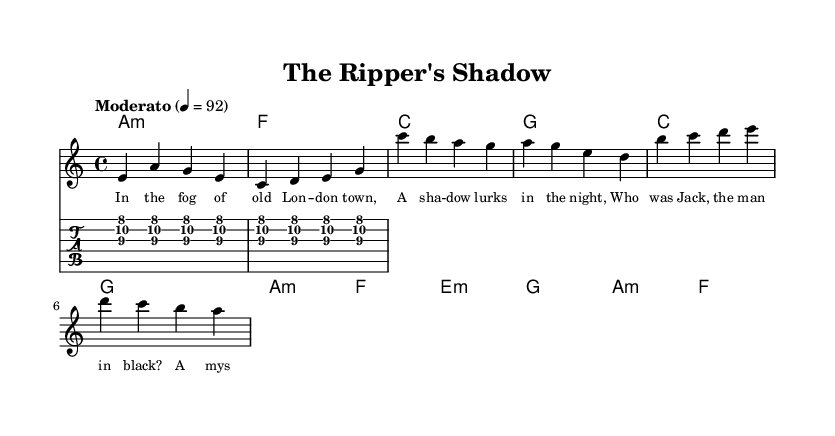What is the key signature of this music? The key signature is A minor, which is indicated by no sharps or flats but has a relative major of C major.
Answer: A minor What is the time signature of this music? The time signature is 4/4, meaning there are four beats in a measure and a quarter note receives one beat. This is common in many musical styles.
Answer: 4/4 What is the tempo marking for this piece? The tempo marking is "Moderato," which generally means a moderate speed or tempo, around 92 beats per minute is indicated in this score.
Answer: Moderato What chord follows the first measure of the verse? The chord that follows the first measure of the verse is A minor, which is represented by the notation "a1:m" alongside the melody notes.
Answer: A minor How many measures are in the chorus section? There are four measures in the chorus section based on the melody notation and corresponding chord changes aligned with the lyrics.
Answer: Four Which historical figure is referenced in the lyrics? The lyrics reference "Jack," referring to Jack the Ripper, a notorious figure related to historical crimes in London.
Answer: Jack What is the structure of the song? The structure consists of a verse, followed by a chorus and then a bridge, indicated by the separation in the melody and lyrics sections.
Answer: Verse, Chorus, Bridge 